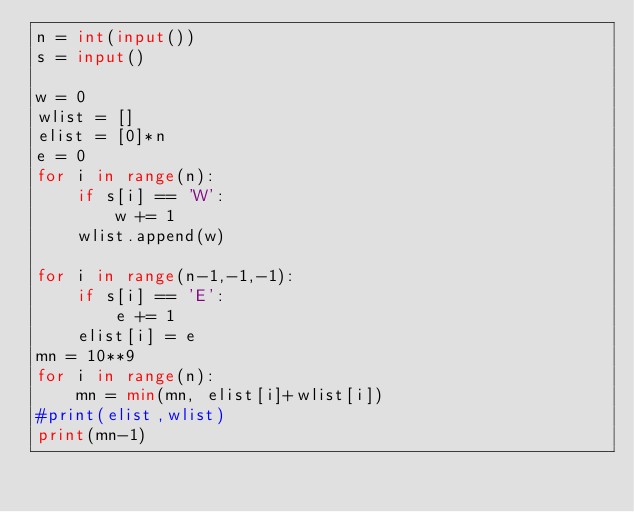<code> <loc_0><loc_0><loc_500><loc_500><_Python_>n = int(input())
s = input()

w = 0
wlist = []
elist = [0]*n
e = 0
for i in range(n):
    if s[i] == 'W':
        w += 1
    wlist.append(w)

for i in range(n-1,-1,-1):
    if s[i] == 'E':
        e += 1
    elist[i] = e
mn = 10**9
for i in range(n):
    mn = min(mn, elist[i]+wlist[i])
#print(elist,wlist)
print(mn-1)</code> 